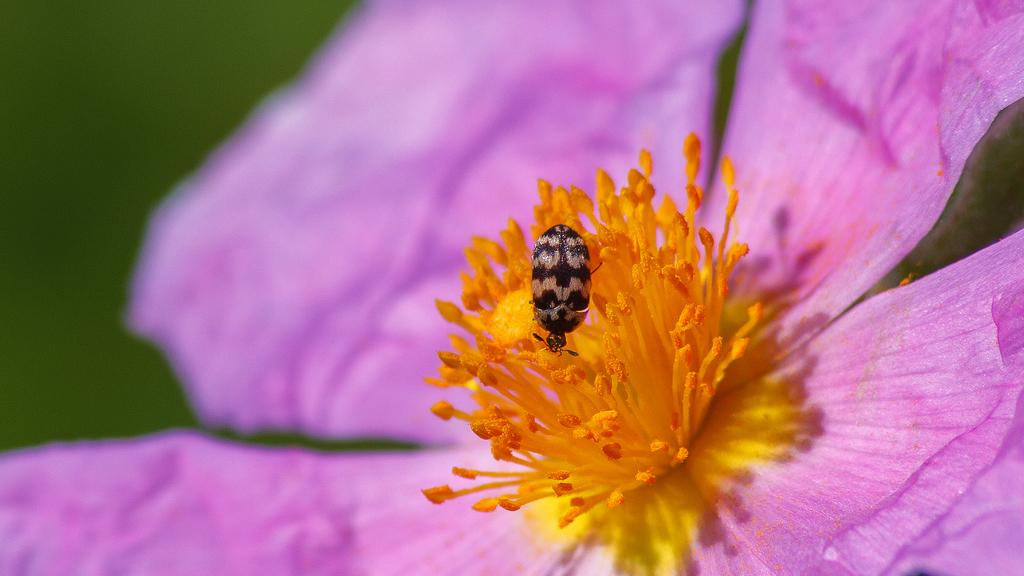What is the main subject of the image? There is a flower in the image. Can you describe the colors of the flower? The flower has orange and pink colors. Are there any other living creatures visible in the image? Yes, there is a small bug near the flower. Where is the nearest store to buy magic potions in the image? There is no store or mention of magic potions in the image; it features a flower with orange and pink colors and a small bug near it. 